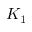<formula> <loc_0><loc_0><loc_500><loc_500>K _ { 1 }</formula> 